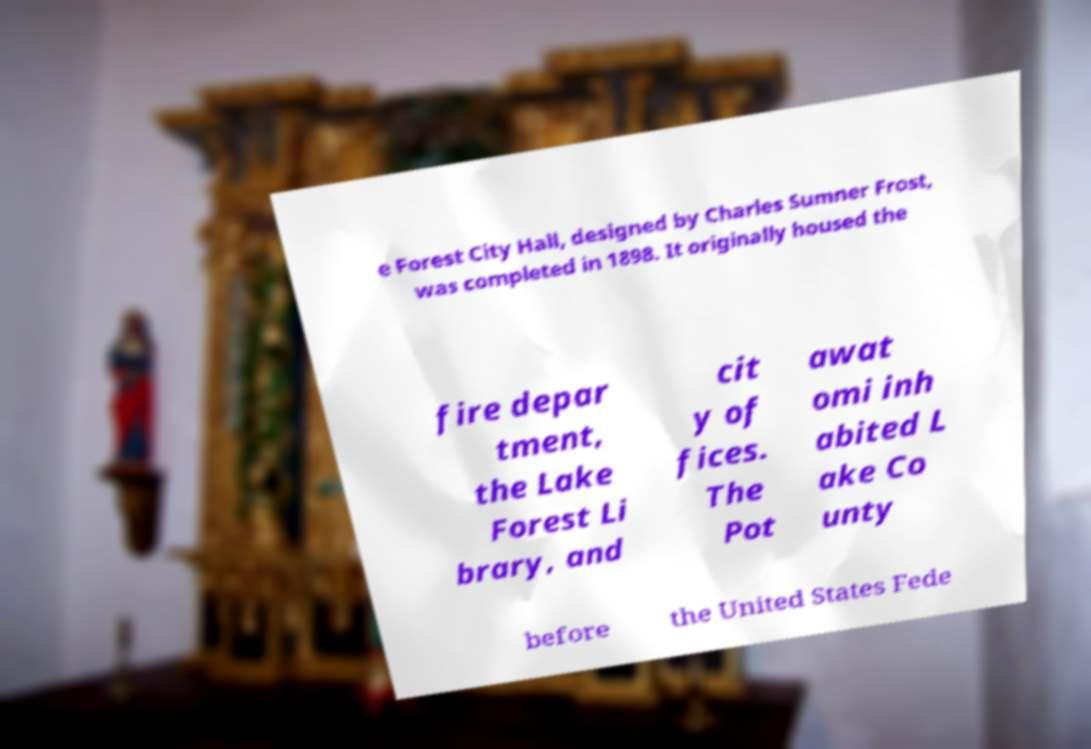Please identify and transcribe the text found in this image. e Forest City Hall, designed by Charles Sumner Frost, was completed in 1898. It originally housed the fire depar tment, the Lake Forest Li brary, and cit y of fices. The Pot awat omi inh abited L ake Co unty before the United States Fede 